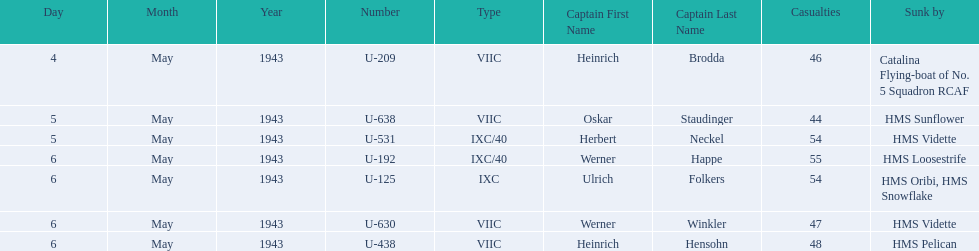What is the list of ships under sunk by? Catalina Flying-boat of No. 5 Squadron RCAF, HMS Sunflower, HMS Vidette, HMS Loosestrife, HMS Oribi, HMS Snowflake, HMS Vidette, HMS Pelican. Which captains did hms pelican sink? Heinrich Hensohn. 